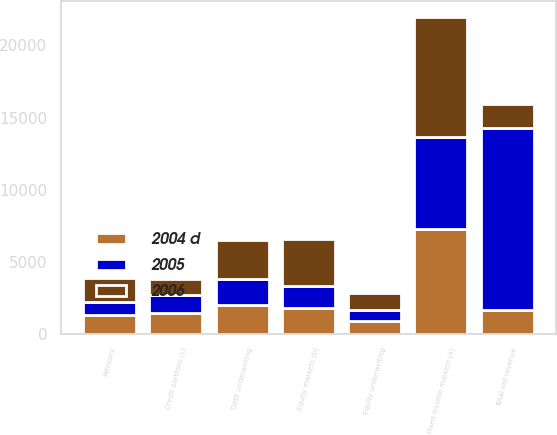<chart> <loc_0><loc_0><loc_500><loc_500><stacked_bar_chart><ecel><fcel>Advisory<fcel>Equity underwriting<fcel>Debt underwriting<fcel>Fixed income markets (a)<fcel>Equity markets (b)<fcel>Credit portfolio (c)<fcel>Total net revenue<nl><fcel>2006<fcel>1659<fcel>1178<fcel>2700<fcel>8369<fcel>3264<fcel>1107<fcel>1659<nl><fcel>2004 d<fcel>1263<fcel>864<fcel>1969<fcel>7277<fcel>1799<fcel>1441<fcel>1659<nl><fcel>2005<fcel>938<fcel>781<fcel>1853<fcel>6342<fcel>1491<fcel>1228<fcel>12633<nl></chart> 